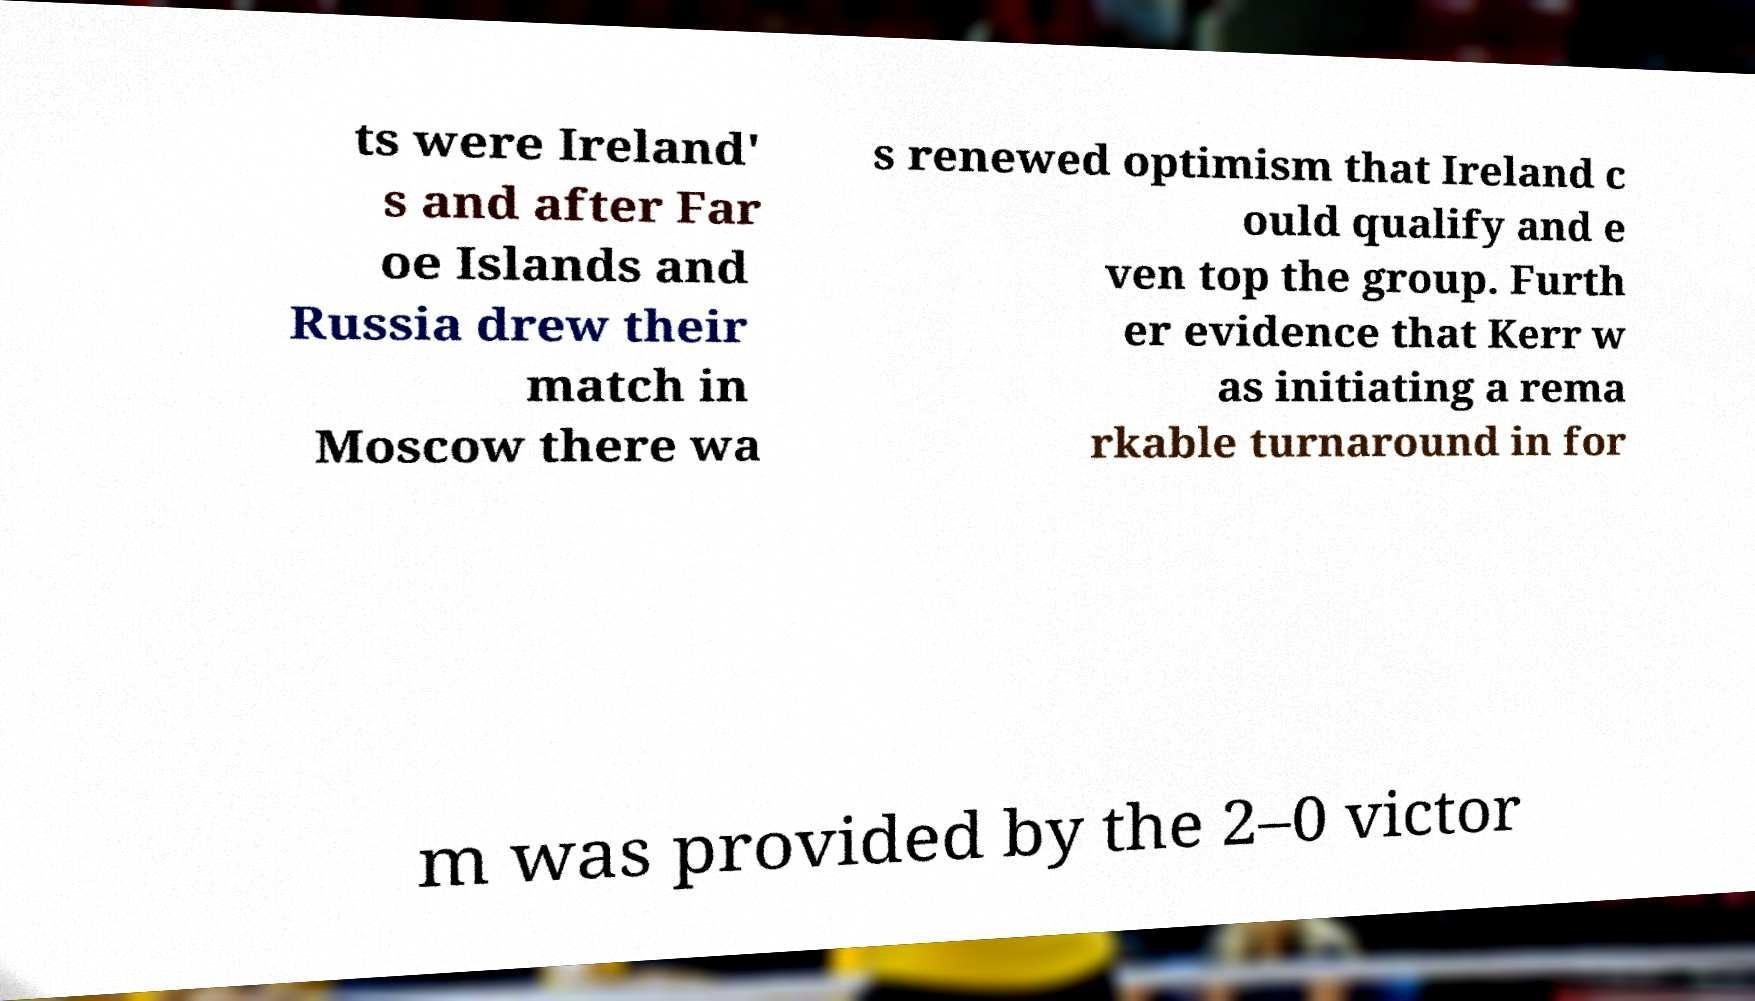Could you assist in decoding the text presented in this image and type it out clearly? ts were Ireland' s and after Far oe Islands and Russia drew their match in Moscow there wa s renewed optimism that Ireland c ould qualify and e ven top the group. Furth er evidence that Kerr w as initiating a rema rkable turnaround in for m was provided by the 2–0 victor 